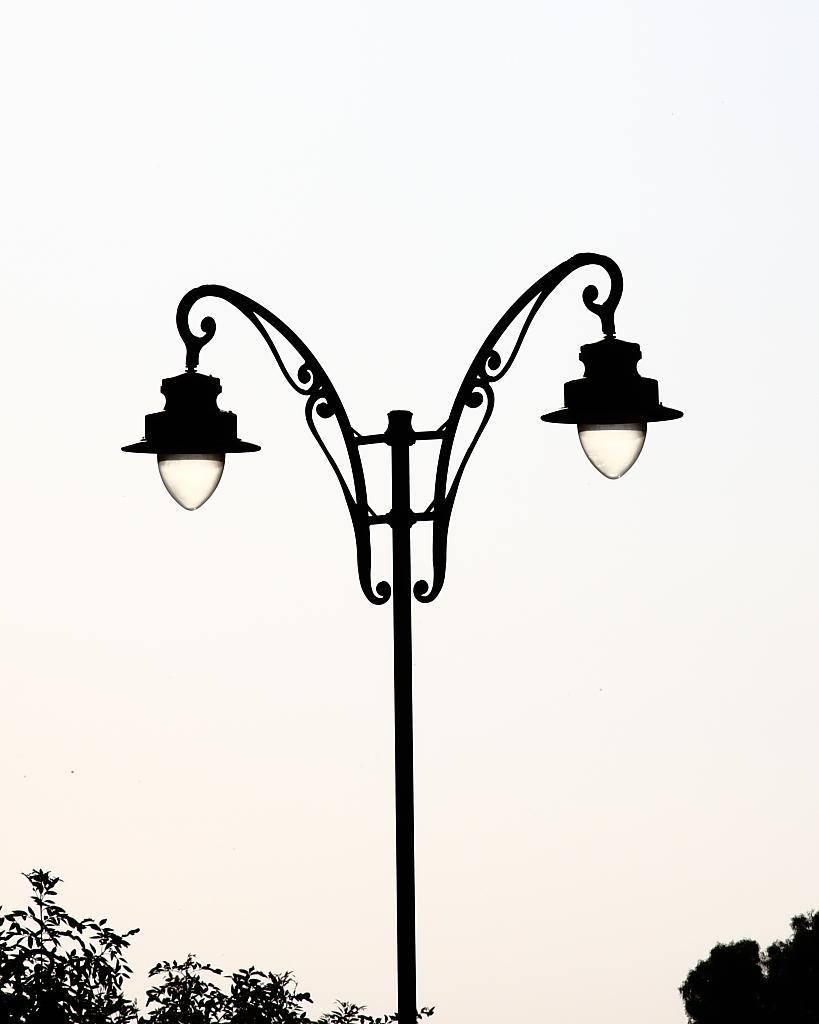How would you summarize this image in a sentence or two? In this image we can see street lights. There are few trees at the bottom of the image. We can see the sky in the image. 